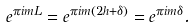Convert formula to latex. <formula><loc_0><loc_0><loc_500><loc_500>e ^ { \pi i m L } = e ^ { \pi i m \left ( 2 h + \delta \right ) } = e ^ { \pi i m \delta } .</formula> 